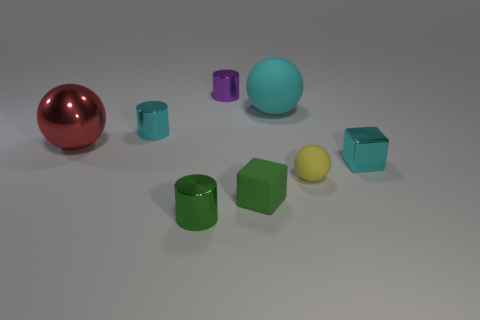Add 1 large metallic things. How many objects exist? 9 Subtract all blocks. How many objects are left? 6 Subtract 1 cyan cylinders. How many objects are left? 7 Subtract all tiny cyan objects. Subtract all small cyan metal things. How many objects are left? 4 Add 6 tiny spheres. How many tiny spheres are left? 7 Add 2 cyan shiny things. How many cyan shiny things exist? 4 